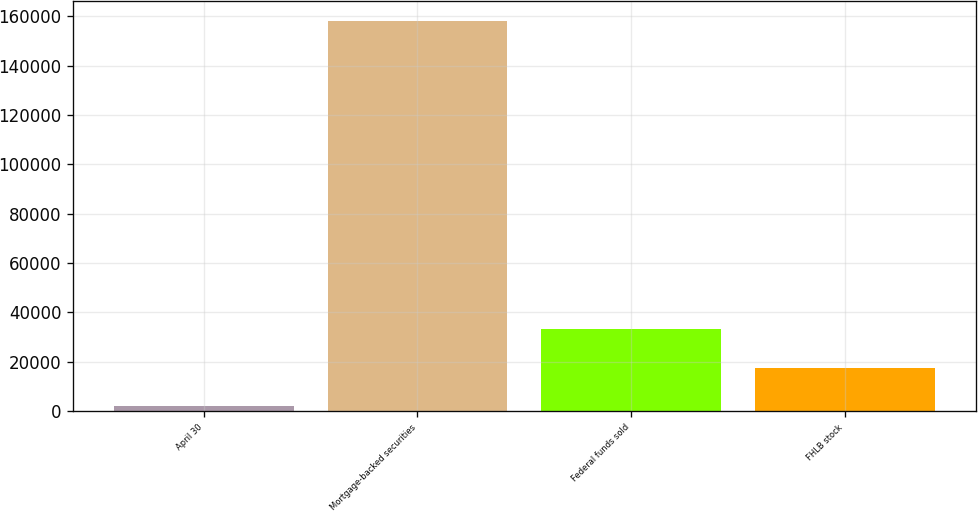<chart> <loc_0><loc_0><loc_500><loc_500><bar_chart><fcel>April 30<fcel>Mortgage-backed securities<fcel>Federal funds sold<fcel>FHLB stock<nl><fcel>2011<fcel>158177<fcel>33244.2<fcel>17627.6<nl></chart> 